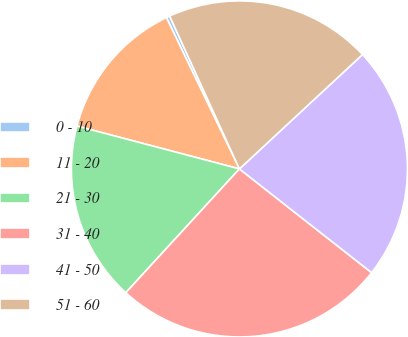Convert chart. <chart><loc_0><loc_0><loc_500><loc_500><pie_chart><fcel>0 - 10<fcel>11 - 20<fcel>21 - 30<fcel>31 - 40<fcel>41 - 50<fcel>51 - 60<nl><fcel>0.34%<fcel>13.74%<fcel>17.29%<fcel>26.23%<fcel>22.51%<fcel>19.9%<nl></chart> 